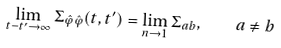<formula> <loc_0><loc_0><loc_500><loc_500>\lim _ { t - t ^ { \prime } \to \infty } \Sigma _ { \hat { \varphi } \hat { \varphi } } ( t , t ^ { \prime } ) = \lim _ { n \to 1 } \Sigma _ { a b } , \quad a \not = b</formula> 